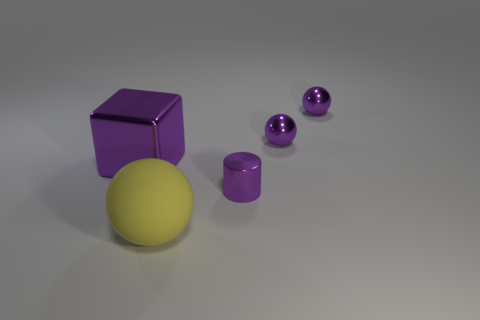Is the material of the big thing behind the big yellow thing the same as the small purple object that is in front of the big purple shiny thing?
Your response must be concise. Yes. Are there any big balls left of the matte object?
Provide a short and direct response. No. How many brown objects are either big blocks or tiny things?
Provide a succinct answer. 0. Does the cylinder have the same material as the big thing that is behind the small cylinder?
Your response must be concise. Yes. What is the material of the yellow thing?
Offer a very short reply. Rubber. What material is the ball in front of the purple metallic thing to the left of the sphere that is in front of the big purple shiny cube?
Make the answer very short. Rubber. Does the purple metallic object on the left side of the big matte ball have the same size as the purple object in front of the metallic block?
Give a very brief answer. No. How many other things are there of the same material as the yellow ball?
Make the answer very short. 0. How many shiny objects are cyan cylinders or tiny objects?
Ensure brevity in your answer.  3. Is the number of purple metal cylinders less than the number of purple objects?
Provide a short and direct response. Yes. 